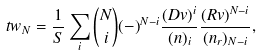<formula> <loc_0><loc_0><loc_500><loc_500>\ t w _ { N } = \frac { 1 } { S } \sum _ { i } { N \choose i } ( - ) ^ { N - i } \frac { ( D v ) ^ { i } } { ( n ) _ { i } } \frac { ( R v ) ^ { N - i } } { ( n _ { r } ) _ { N - i } } ,</formula> 